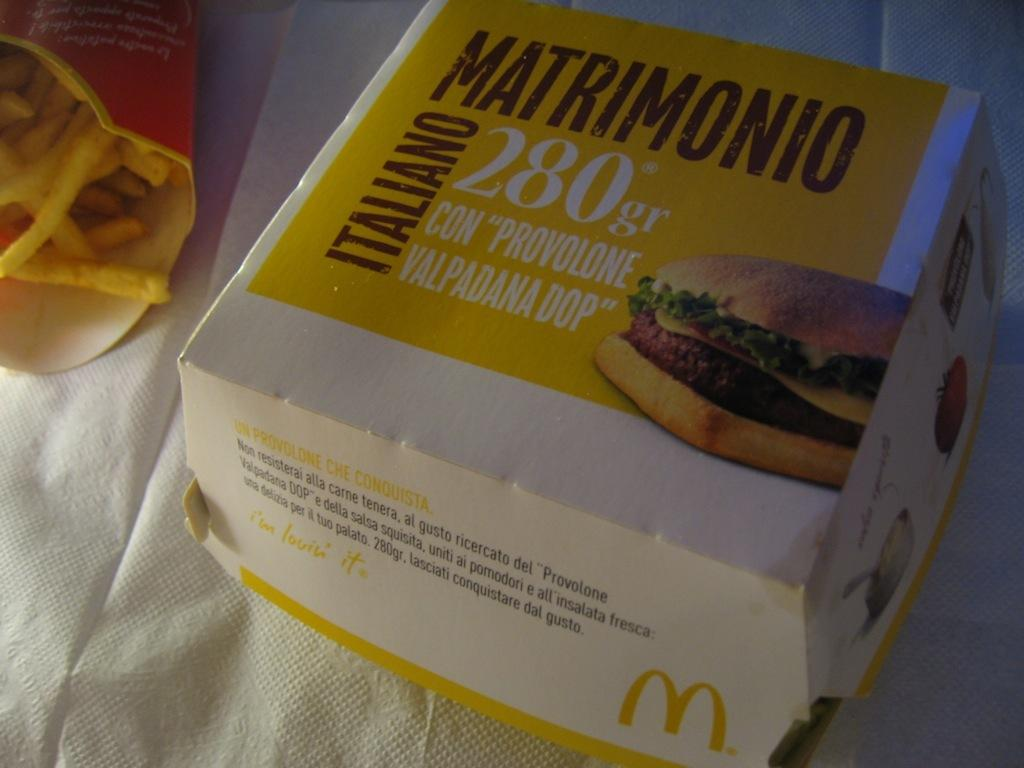What type of food is visible in the image? There are french fries in the image. What other type of food can be seen in the image? There is packed food in the image. Where are the french fries and packed food placed? The french fries and packed food are on a paper napkin. How many babies are visible in the image? There are no babies present in the image. Is there a person holding a knife in the image? There is no person or knife visible in the image. 